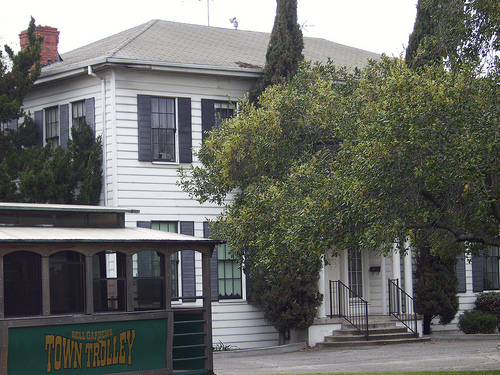<image>
Can you confirm if the house is on the tree? No. The house is not positioned on the tree. They may be near each other, but the house is not supported by or resting on top of the tree. 